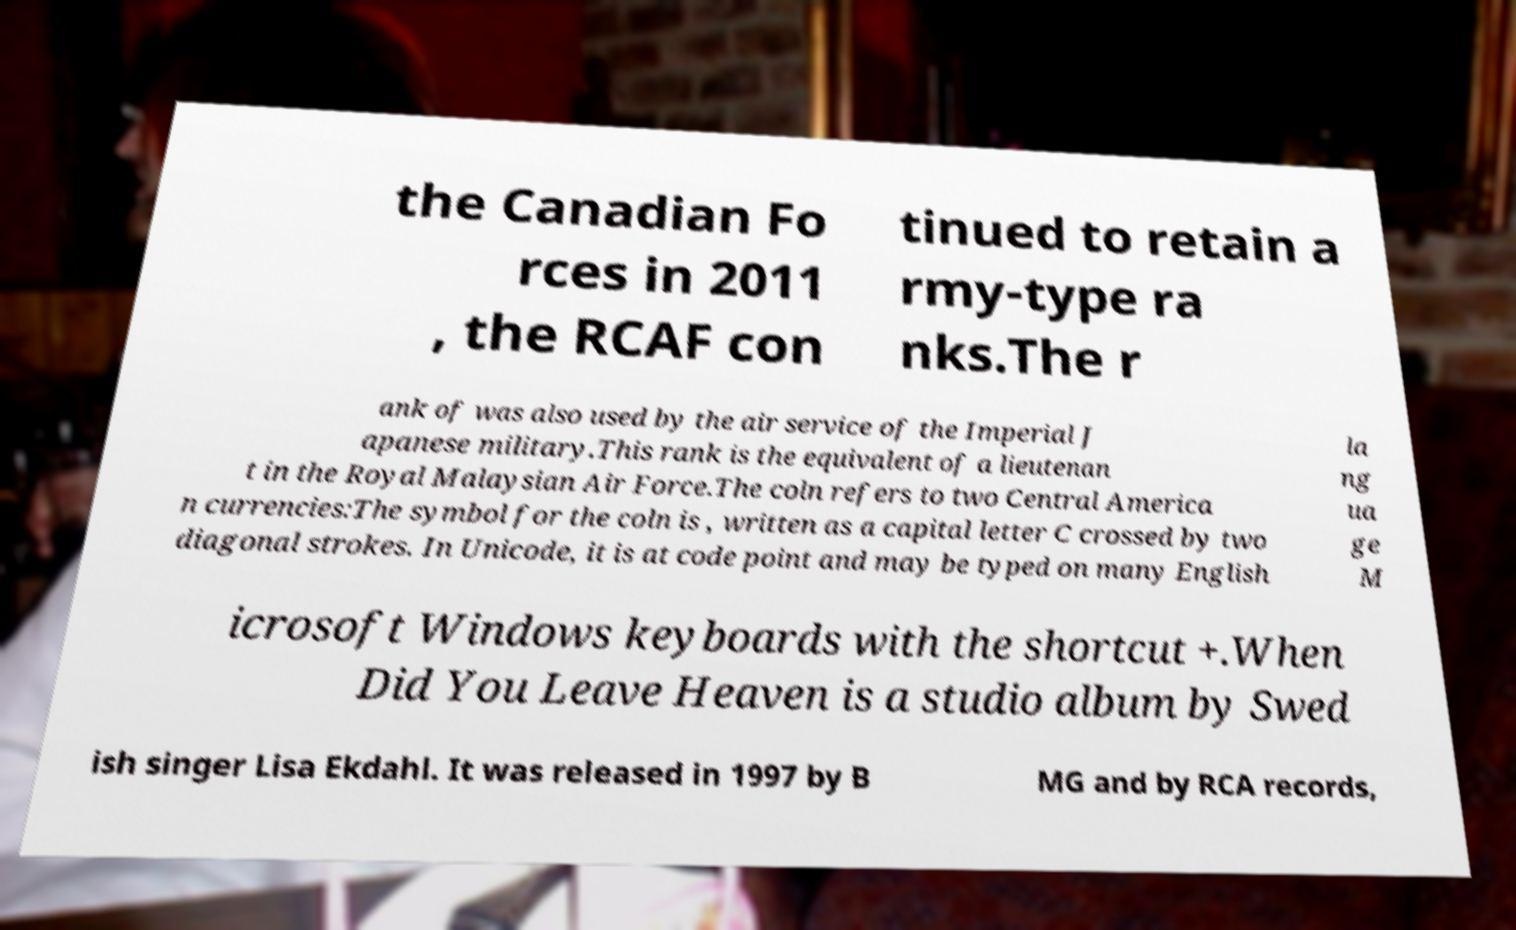Please identify and transcribe the text found in this image. the Canadian Fo rces in 2011 , the RCAF con tinued to retain a rmy-type ra nks.The r ank of was also used by the air service of the Imperial J apanese military.This rank is the equivalent of a lieutenan t in the Royal Malaysian Air Force.The coln refers to two Central America n currencies:The symbol for the coln is , written as a capital letter C crossed by two diagonal strokes. In Unicode, it is at code point and may be typed on many English la ng ua ge M icrosoft Windows keyboards with the shortcut +.When Did You Leave Heaven is a studio album by Swed ish singer Lisa Ekdahl. It was released in 1997 by B MG and by RCA records, 